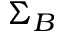Convert formula to latex. <formula><loc_0><loc_0><loc_500><loc_500>\Sigma _ { B }</formula> 